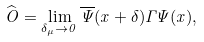<formula> <loc_0><loc_0><loc_500><loc_500>\widehat { O } = \lim _ { \delta _ { \mu } \rightarrow 0 } \overline { \Psi } ( x + \delta ) \Gamma \Psi ( x ) ,</formula> 